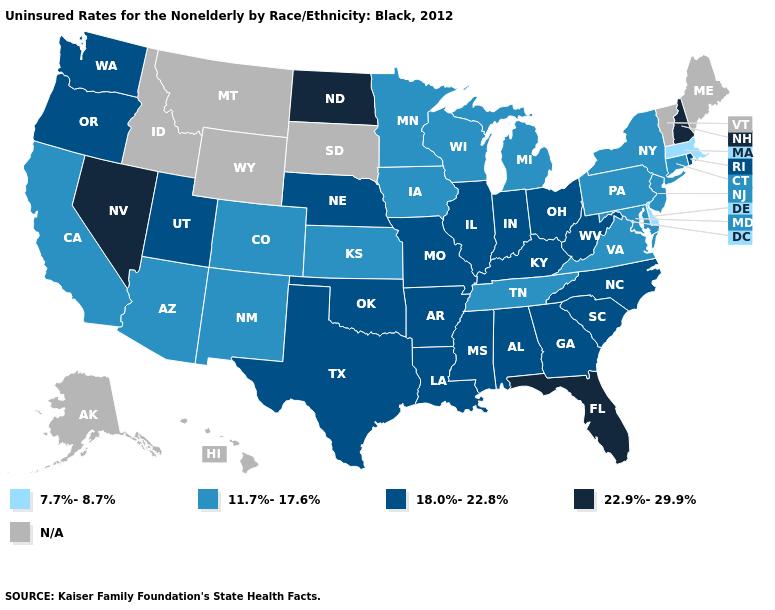Name the states that have a value in the range N/A?
Answer briefly. Alaska, Hawaii, Idaho, Maine, Montana, South Dakota, Vermont, Wyoming. Name the states that have a value in the range N/A?
Short answer required. Alaska, Hawaii, Idaho, Maine, Montana, South Dakota, Vermont, Wyoming. What is the lowest value in the USA?
Short answer required. 7.7%-8.7%. What is the value of Louisiana?
Give a very brief answer. 18.0%-22.8%. Is the legend a continuous bar?
Quick response, please. No. How many symbols are there in the legend?
Quick response, please. 5. What is the value of Montana?
Answer briefly. N/A. Which states have the lowest value in the USA?
Write a very short answer. Delaware, Massachusetts. Name the states that have a value in the range N/A?
Answer briefly. Alaska, Hawaii, Idaho, Maine, Montana, South Dakota, Vermont, Wyoming. What is the value of Alaska?
Short answer required. N/A. Does Florida have the highest value in the South?
Keep it brief. Yes. What is the value of California?
Concise answer only. 11.7%-17.6%. Does West Virginia have the lowest value in the USA?
Quick response, please. No. 